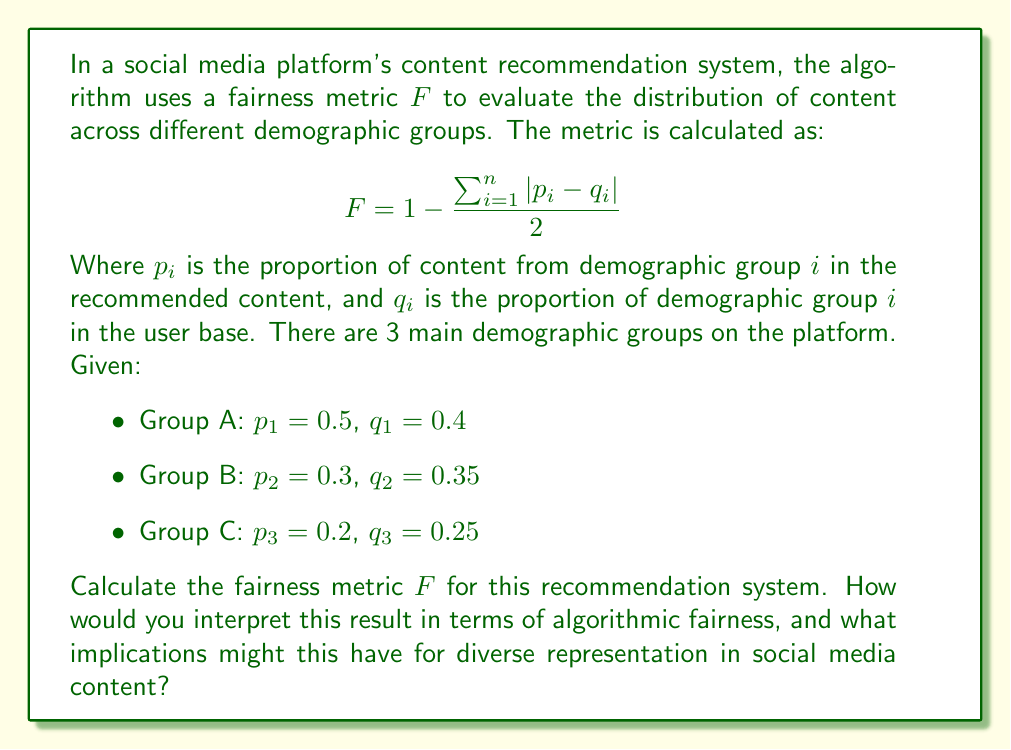Provide a solution to this math problem. To solve this problem, we'll follow these steps:

1) First, let's calculate $|p_i - q_i|$ for each group:

   Group A: $|p_1 - q_1| = |0.5 - 0.4| = 0.1$
   Group B: $|p_2 - q_2| = |0.3 - 0.35| = 0.05$
   Group C: $|p_3 - q_3| = |0.2 - 0.25| = 0.05$

2) Now, we sum these differences:

   $\sum_{i=1}^{n} |p_i - q_i| = 0.1 + 0.05 + 0.05 = 0.2$

3) We can now plug this into our fairness metric formula:

   $$F = 1 - \frac{0.2}{2} = 1 - 0.1 = 0.9$$

4) Interpretation:
   The fairness metric $F$ ranges from 0 to 1, where 1 represents perfect fairness (the recommended content exactly matches the demographic proportions of the user base), and 0 represents complete unfairness.

   A score of 0.9 indicates a high level of fairness in the recommendation system. However, it's not perfect, and there's still a slight bias in the recommendations.

   Looking at the individual groups:
   - Group A is overrepresented in the recommendations (50% of recommendations vs 40% of user base)
   - Groups B and C are slightly underrepresented

   This could lead to amplification of Group A's content and perspectives, potentially drowning out minority voices. While the overall fairness is high, there's still room for improvement in terms of equal representation.

5) Implications for diverse representation:
   - The slight bias could lead to a feedback loop where Group A's content becomes increasingly dominant over time.
   - Users from Groups B and C might feel underrepresented and less engaged with the platform.
   - The platform might consider adjusting its algorithm to achieve more equal representation, perhaps by setting a higher threshold for the fairness metric.
   - Educators and social scientists might use this as a case study to discuss the challenges of achieving perfect fairness in algorithmic systems and the potential societal impacts of even small biases in widely-used platforms.
Answer: The fairness metric $F$ for this recommendation system is 0.9. This indicates a high level of fairness, but with a slight bias favoring Group A at the expense of Groups B and C. While generally fair, this system could potentially lead to amplification of majority perspectives and underrepresentation of minority voices over time. 